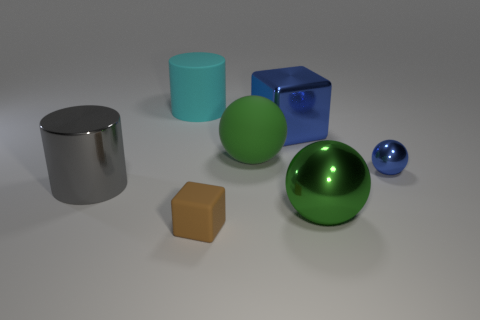Subtract all red cubes. How many green spheres are left? 2 Add 3 big green metallic objects. How many objects exist? 10 Subtract all cylinders. How many objects are left? 5 Add 3 small blue cubes. How many small blue cubes exist? 3 Subtract 0 red spheres. How many objects are left? 7 Subtract all big matte cylinders. Subtract all big green matte balls. How many objects are left? 5 Add 1 big green objects. How many big green objects are left? 3 